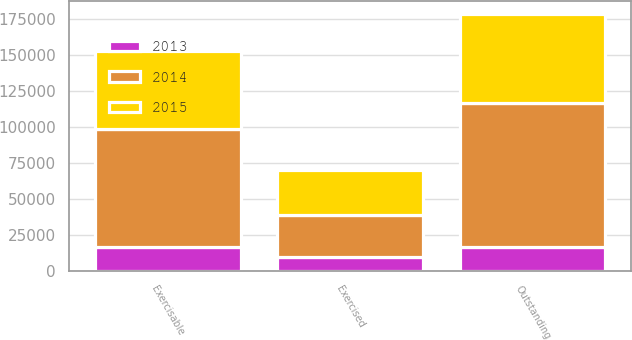Convert chart to OTSL. <chart><loc_0><loc_0><loc_500><loc_500><stacked_bar_chart><ecel><fcel>Exercised<fcel>Outstanding<fcel>Exercisable<nl><fcel>2013<fcel>9890<fcel>16605<fcel>16605<nl><fcel>2015<fcel>31623<fcel>61947<fcel>54071<nl><fcel>2014<fcel>28879<fcel>100054<fcel>81930<nl></chart> 